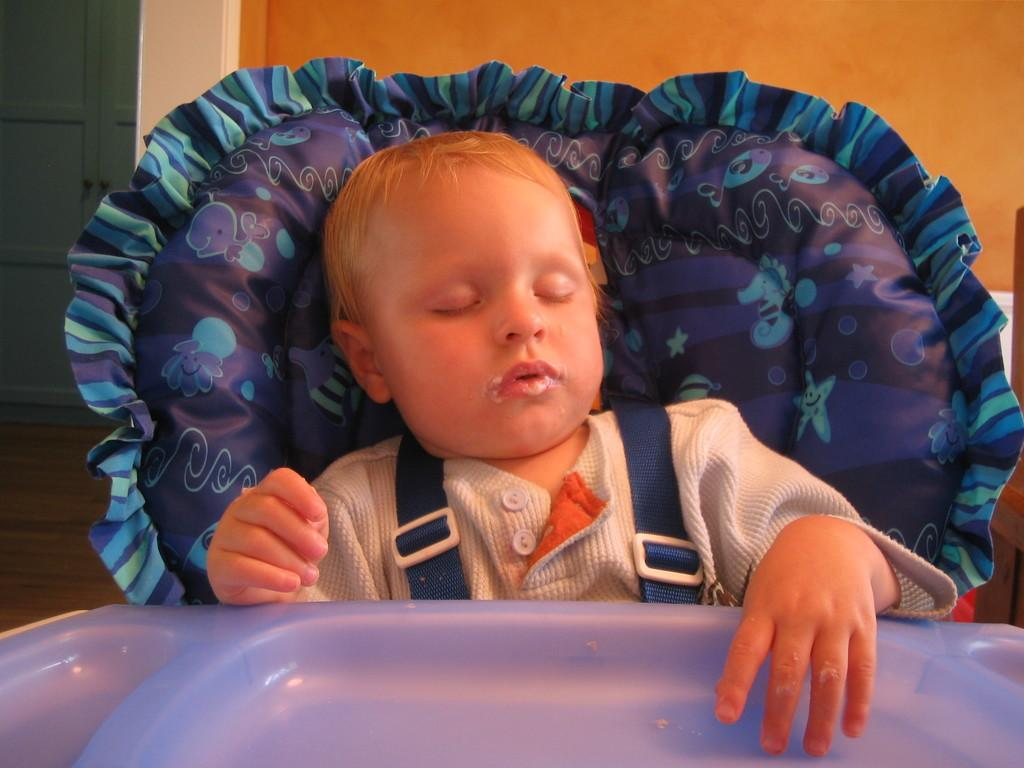What is the kid in the image doing? The kid is sleeping in the image. What is supporting the kid's head while they sleep? There is a cushion behind the kid. What is in front of the kid? There is a plate in front of the kid. What can be seen in the background of the image? There is a wall visible in the image, and a closet is also present. What type of snow can be seen falling outside the window in the image? There is no window or snow present in the image; it only shows a kid sleeping with a cushion behind them, a plate in front of them, and a wall with a closet in the background. 